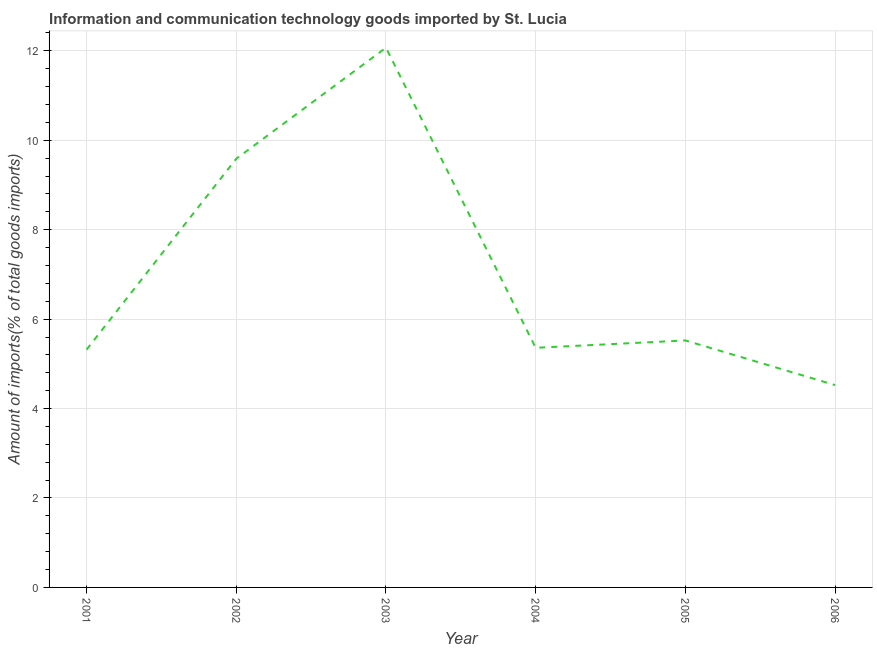What is the amount of ict goods imports in 2003?
Offer a very short reply. 12.07. Across all years, what is the maximum amount of ict goods imports?
Offer a terse response. 12.07. Across all years, what is the minimum amount of ict goods imports?
Offer a very short reply. 4.53. In which year was the amount of ict goods imports maximum?
Offer a very short reply. 2003. What is the sum of the amount of ict goods imports?
Provide a succinct answer. 42.38. What is the difference between the amount of ict goods imports in 2001 and 2003?
Ensure brevity in your answer.  -6.75. What is the average amount of ict goods imports per year?
Provide a succinct answer. 7.06. What is the median amount of ict goods imports?
Your answer should be compact. 5.44. Do a majority of the years between 2003 and 2002 (inclusive) have amount of ict goods imports greater than 4 %?
Offer a terse response. No. What is the ratio of the amount of ict goods imports in 2004 to that in 2006?
Give a very brief answer. 1.18. Is the difference between the amount of ict goods imports in 2002 and 2006 greater than the difference between any two years?
Ensure brevity in your answer.  No. What is the difference between the highest and the second highest amount of ict goods imports?
Your answer should be very brief. 2.48. Is the sum of the amount of ict goods imports in 2004 and 2005 greater than the maximum amount of ict goods imports across all years?
Offer a terse response. No. What is the difference between the highest and the lowest amount of ict goods imports?
Keep it short and to the point. 7.54. In how many years, is the amount of ict goods imports greater than the average amount of ict goods imports taken over all years?
Make the answer very short. 2. Does the amount of ict goods imports monotonically increase over the years?
Your response must be concise. No. How many lines are there?
Offer a very short reply. 1. What is the difference between two consecutive major ticks on the Y-axis?
Give a very brief answer. 2. Are the values on the major ticks of Y-axis written in scientific E-notation?
Offer a terse response. No. What is the title of the graph?
Your response must be concise. Information and communication technology goods imported by St. Lucia. What is the label or title of the Y-axis?
Your answer should be very brief. Amount of imports(% of total goods imports). What is the Amount of imports(% of total goods imports) of 2001?
Ensure brevity in your answer.  5.32. What is the Amount of imports(% of total goods imports) of 2002?
Give a very brief answer. 9.59. What is the Amount of imports(% of total goods imports) in 2003?
Your response must be concise. 12.07. What is the Amount of imports(% of total goods imports) of 2004?
Keep it short and to the point. 5.36. What is the Amount of imports(% of total goods imports) in 2005?
Your answer should be very brief. 5.52. What is the Amount of imports(% of total goods imports) in 2006?
Offer a terse response. 4.53. What is the difference between the Amount of imports(% of total goods imports) in 2001 and 2002?
Provide a succinct answer. -4.27. What is the difference between the Amount of imports(% of total goods imports) in 2001 and 2003?
Offer a very short reply. -6.75. What is the difference between the Amount of imports(% of total goods imports) in 2001 and 2004?
Provide a succinct answer. -0.04. What is the difference between the Amount of imports(% of total goods imports) in 2001 and 2005?
Give a very brief answer. -0.21. What is the difference between the Amount of imports(% of total goods imports) in 2001 and 2006?
Your answer should be compact. 0.79. What is the difference between the Amount of imports(% of total goods imports) in 2002 and 2003?
Provide a short and direct response. -2.48. What is the difference between the Amount of imports(% of total goods imports) in 2002 and 2004?
Your answer should be compact. 4.23. What is the difference between the Amount of imports(% of total goods imports) in 2002 and 2005?
Your answer should be compact. 4.06. What is the difference between the Amount of imports(% of total goods imports) in 2002 and 2006?
Provide a short and direct response. 5.06. What is the difference between the Amount of imports(% of total goods imports) in 2003 and 2004?
Offer a very short reply. 6.71. What is the difference between the Amount of imports(% of total goods imports) in 2003 and 2005?
Offer a very short reply. 6.55. What is the difference between the Amount of imports(% of total goods imports) in 2003 and 2006?
Your response must be concise. 7.54. What is the difference between the Amount of imports(% of total goods imports) in 2004 and 2005?
Ensure brevity in your answer.  -0.16. What is the difference between the Amount of imports(% of total goods imports) in 2004 and 2006?
Your answer should be compact. 0.83. What is the difference between the Amount of imports(% of total goods imports) in 2005 and 2006?
Offer a terse response. 1. What is the ratio of the Amount of imports(% of total goods imports) in 2001 to that in 2002?
Ensure brevity in your answer.  0.56. What is the ratio of the Amount of imports(% of total goods imports) in 2001 to that in 2003?
Offer a terse response. 0.44. What is the ratio of the Amount of imports(% of total goods imports) in 2001 to that in 2005?
Make the answer very short. 0.96. What is the ratio of the Amount of imports(% of total goods imports) in 2001 to that in 2006?
Your answer should be compact. 1.18. What is the ratio of the Amount of imports(% of total goods imports) in 2002 to that in 2003?
Ensure brevity in your answer.  0.79. What is the ratio of the Amount of imports(% of total goods imports) in 2002 to that in 2004?
Your response must be concise. 1.79. What is the ratio of the Amount of imports(% of total goods imports) in 2002 to that in 2005?
Your answer should be very brief. 1.74. What is the ratio of the Amount of imports(% of total goods imports) in 2002 to that in 2006?
Your response must be concise. 2.12. What is the ratio of the Amount of imports(% of total goods imports) in 2003 to that in 2004?
Make the answer very short. 2.25. What is the ratio of the Amount of imports(% of total goods imports) in 2003 to that in 2005?
Ensure brevity in your answer.  2.19. What is the ratio of the Amount of imports(% of total goods imports) in 2003 to that in 2006?
Keep it short and to the point. 2.67. What is the ratio of the Amount of imports(% of total goods imports) in 2004 to that in 2006?
Provide a short and direct response. 1.18. What is the ratio of the Amount of imports(% of total goods imports) in 2005 to that in 2006?
Ensure brevity in your answer.  1.22. 